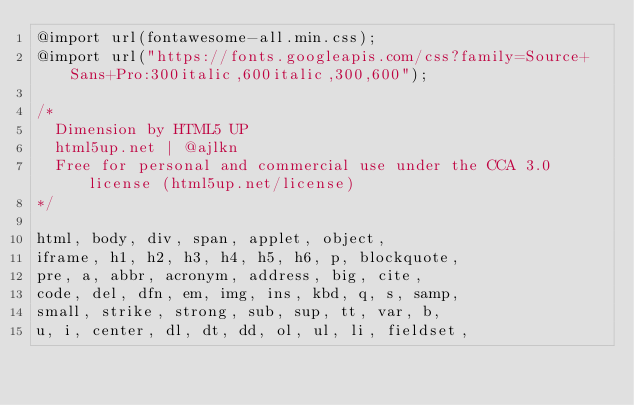Convert code to text. <code><loc_0><loc_0><loc_500><loc_500><_CSS_>@import url(fontawesome-all.min.css);
@import url("https://fonts.googleapis.com/css?family=Source+Sans+Pro:300italic,600italic,300,600");

/*
	Dimension by HTML5 UP
	html5up.net | @ajlkn
	Free for personal and commercial use under the CCA 3.0 license (html5up.net/license)
*/

html, body, div, span, applet, object,
iframe, h1, h2, h3, h4, h5, h6, p, blockquote,
pre, a, abbr, acronym, address, big, cite,
code, del, dfn, em, img, ins, kbd, q, s, samp,
small, strike, strong, sub, sup, tt, var, b,
u, i, center, dl, dt, dd, ol, ul, li, fieldset,</code> 